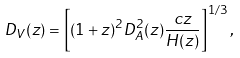Convert formula to latex. <formula><loc_0><loc_0><loc_500><loc_500>D _ { V } ( z ) = \left [ ( 1 + z ) ^ { 2 } D _ { A } ^ { 2 } ( z ) \frac { c z } { H ( z ) } \right ] ^ { 1 / 3 } ,</formula> 